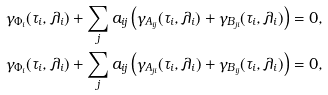Convert formula to latex. <formula><loc_0><loc_0><loc_500><loc_500>\gamma _ { \Phi _ { i } } ( \tau _ { i } , \lambda _ { i } ) + \sum _ { j } a _ { i j } \left ( \gamma _ { A _ { i j } } ( \tau _ { i } , \lambda _ { i } ) + \gamma _ { B _ { j i } } ( \tau _ { i } , \lambda _ { i } ) \right ) = 0 , \\ \gamma _ { \Phi _ { i } } ( \tau _ { i } , \lambda _ { i } ) + \sum _ { j } a _ { i j } \left ( \gamma _ { A _ { j i } } ( \tau _ { i } , \lambda _ { i } ) + \gamma _ { B _ { i j } } ( \tau _ { i } , \lambda _ { i } ) \right ) = 0 ,</formula> 